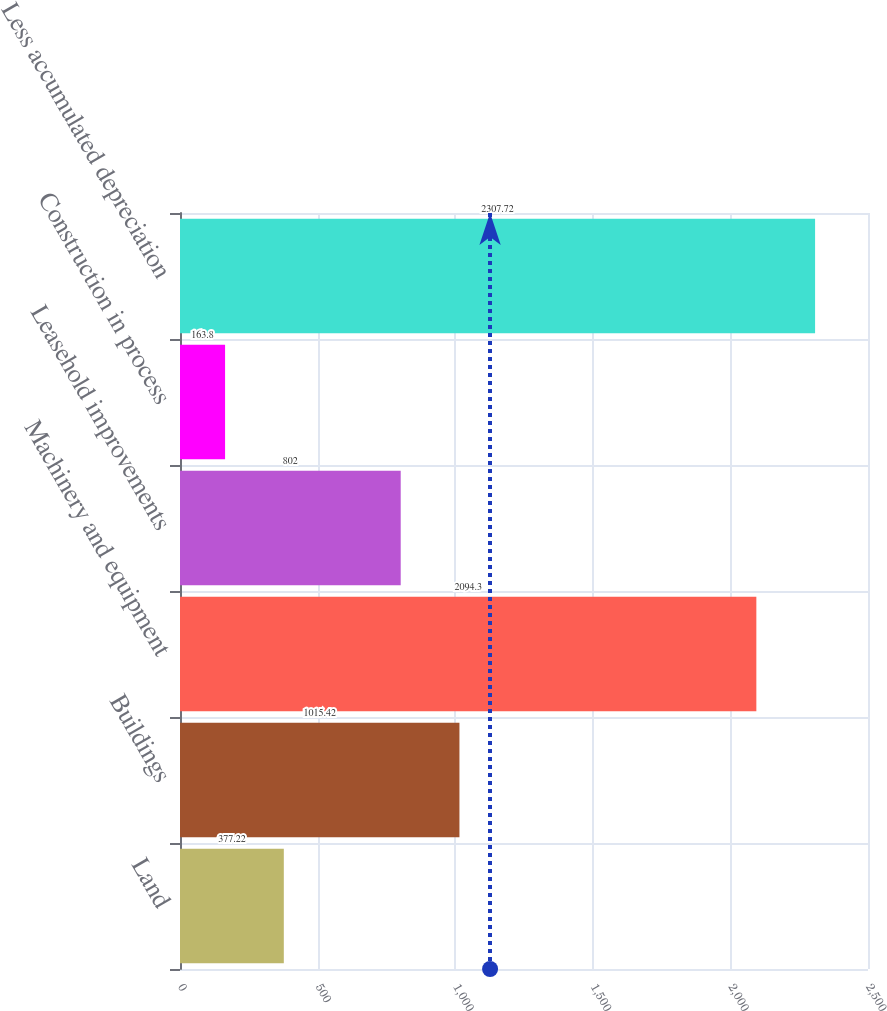<chart> <loc_0><loc_0><loc_500><loc_500><bar_chart><fcel>Land<fcel>Buildings<fcel>Machinery and equipment<fcel>Leasehold improvements<fcel>Construction in process<fcel>Less accumulated depreciation<nl><fcel>377.22<fcel>1015.42<fcel>2094.3<fcel>802<fcel>163.8<fcel>2307.72<nl></chart> 